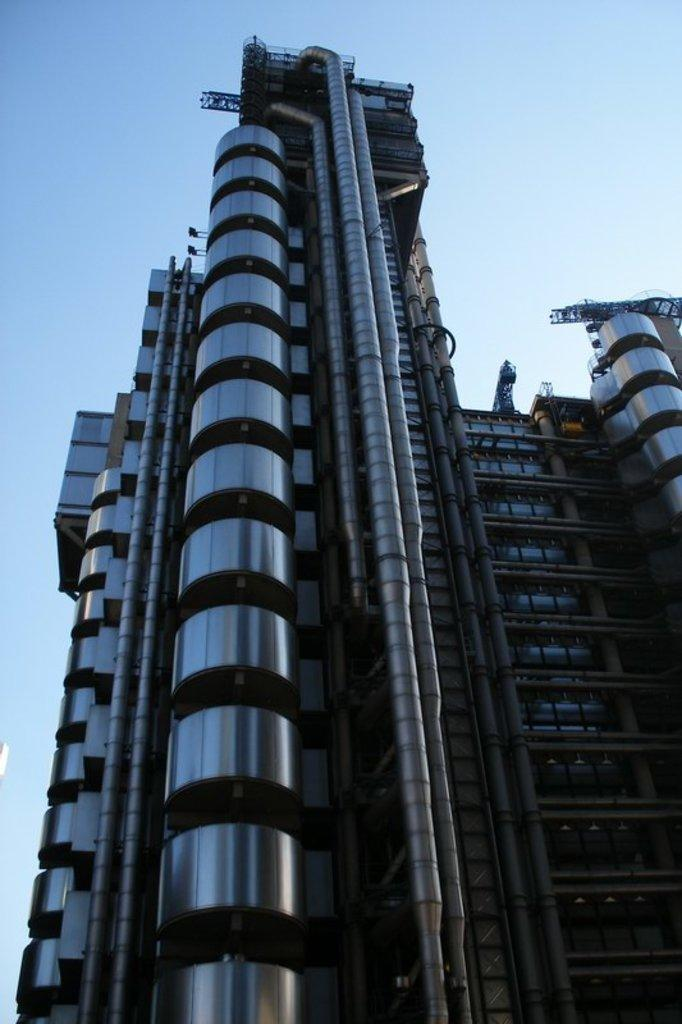What type of structure is the main subject of the picture? There is a tower building in the picture. What can be seen on the wall of the building? Ventilation pipes are present on the wall of the building. What is visible in the sky in the picture? There are clouds in the sky. What type of soap is being offered to the clouds in the image? There is no soap or offer being made to the clouds in the image. The image only features a tower building with ventilation pipes and clouds in the sky. 